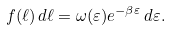Convert formula to latex. <formula><loc_0><loc_0><loc_500><loc_500>f ( \ell ) \, d \ell = \omega ( \varepsilon ) e ^ { - \beta \varepsilon } \, d \varepsilon .</formula> 